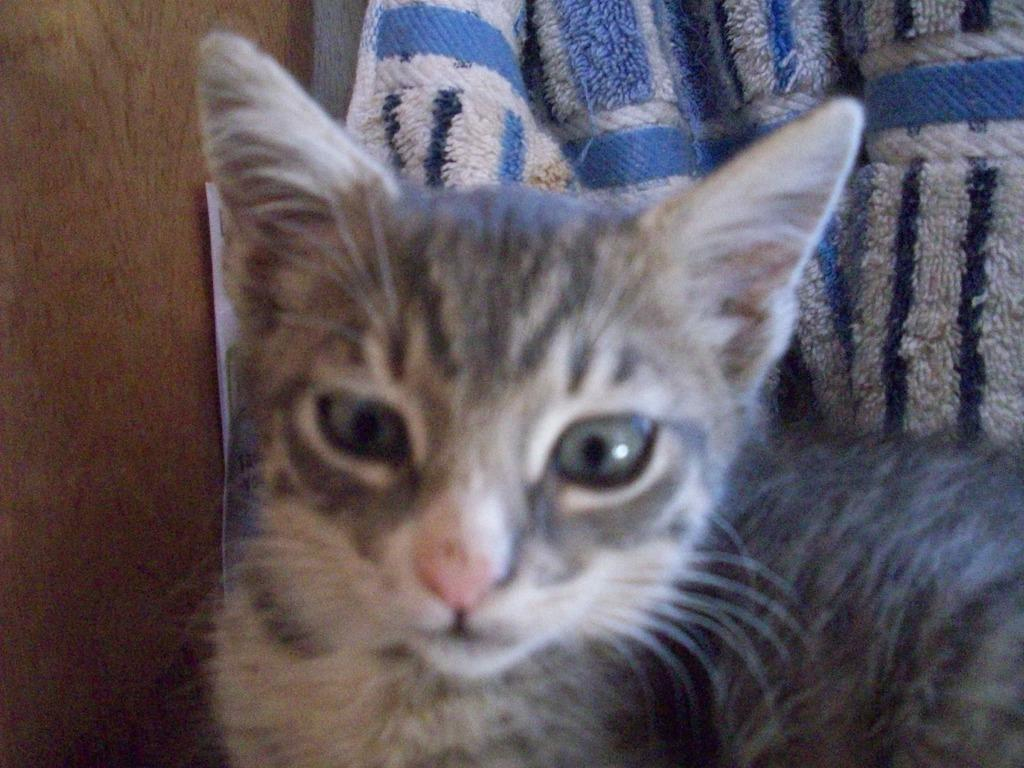What type of animal is in the image? There is a cat in the image. What can be seen in the background of the image? There is a cloth and a wooden board in the background of the image. What type of effect does the umbrella have on the cat in the image? There is no umbrella present in the image, so it is not possible to determine any effect it might have on the cat. 